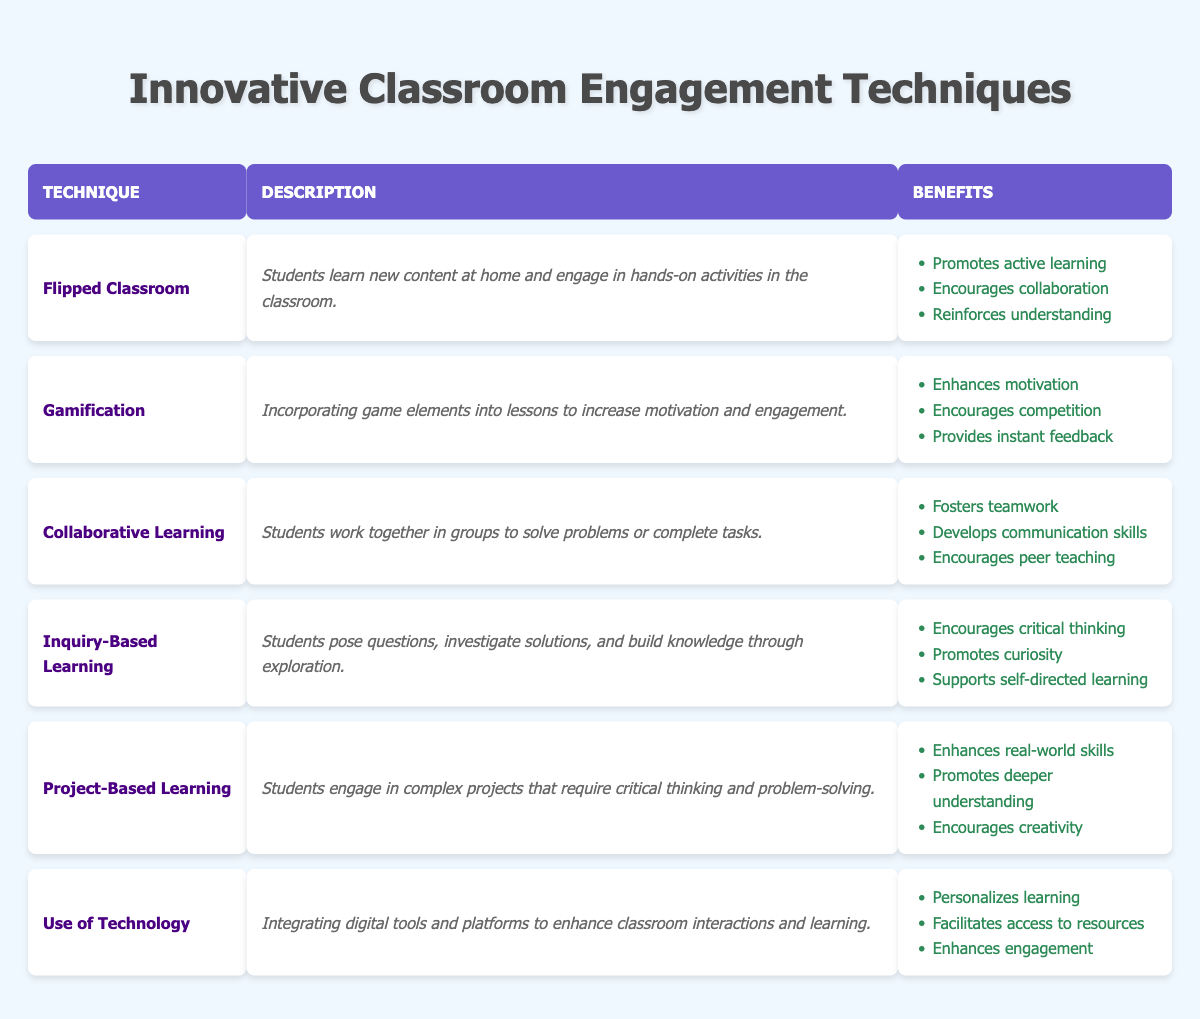What is the technique used that promotes active learning? The table indicates "Flipped Classroom" is the technique that promotes active learning.
Answer: Flipped Classroom How many benefits are listed for Gamification? The table shows that Gamification has three benefits listed: enhances motivation, encourages competition, and provides instant feedback.
Answer: Three Is Inquiry-Based Learning designed to support self-directed learning? Yes, according to the table, one of the benefits of Inquiry-Based Learning is that it supports self-directed learning.
Answer: Yes Which technique encourages collaboration among students? The table indicates that "Flipped Classroom" is one of the techniques that encourages collaboration.
Answer: Flipped Classroom List all the benefits of Project-Based Learning. Project-Based Learning has three benefits: enhances real-world skills, promotes deeper understanding, and encourages creativity.
Answer: Enhances real-world skills, promotes deeper understanding, encourages creativity How many techniques involve teamwork as a benefit? Two techniques involve teamwork as a benefit: Collaborative Learning and Flipped Classroom.
Answer: Two Is the use of technology one of the techniques listed? Yes, the table lists "Use of Technology" as one of the techniques.
Answer: Yes Which technique has the benefit of developing communication skills? The technique "Collaborative Learning" has the benefit of developing communication skills.
Answer: Collaborative Learning Among all techniques, which one primarily focuses on hands-on activities in class? The "Flipped Classroom" focuses on hands-on activities in the classroom after learning new content at home.
Answer: Flipped Classroom If a student engages in inquiry-based learning, what key skill are they likely to develop? A student engaging in inquiry-based learning is likely to develop critical thinking skills, as stated in the benefits of this technique.
Answer: Critical thinking What technique provides instant feedback as one of its benefits? The technique "Gamification" provides instant feedback among its benefits.
Answer: Gamification Which classroom engagement technique could potentially enhance motivation through competition? The technique "Gamification" enhances motivation through competition.
Answer: Gamification If a teacher wants to promote curiosity, which technique should they consider using? They should consider using "Inquiry-Based Learning," as one of its benefits is to promote curiosity.
Answer: Inquiry-Based Learning In total, how many techniques are detailed in the table? There are six techniques detailed in the table.
Answer: Six What is a common benefit of both Inquiry-Based Learning and Project-Based Learning? Both Inquiry-Based Learning and Project-Based Learning encourage deeper understanding of the subject matter.
Answer: Encourages deeper understanding 